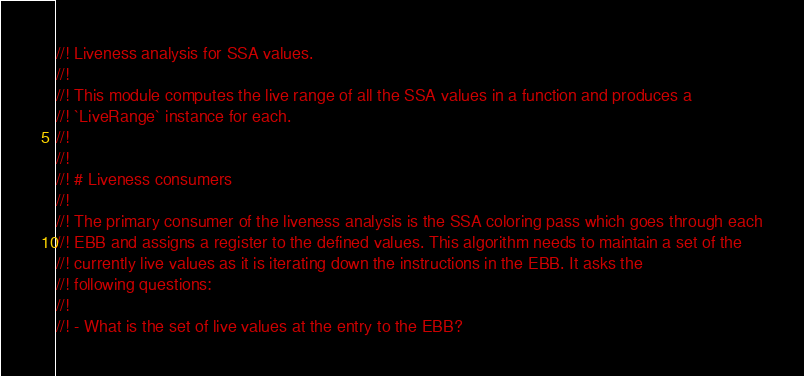Convert code to text. <code><loc_0><loc_0><loc_500><loc_500><_Rust_>//! Liveness analysis for SSA values.
//!
//! This module computes the live range of all the SSA values in a function and produces a
//! `LiveRange` instance for each.
//!
//!
//! # Liveness consumers
//!
//! The primary consumer of the liveness analysis is the SSA coloring pass which goes through each
//! EBB and assigns a register to the defined values. This algorithm needs to maintain a set of the
//! currently live values as it is iterating down the instructions in the EBB. It asks the
//! following questions:
//!
//! - What is the set of live values at the entry to the EBB?</code> 